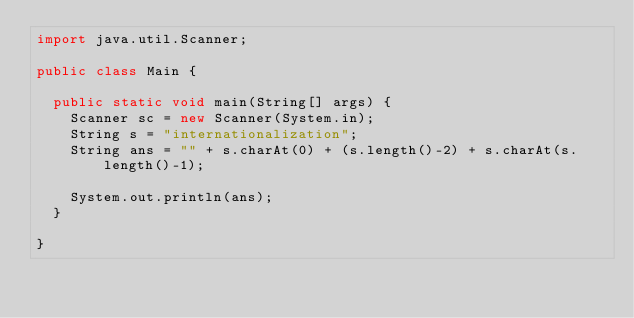Convert code to text. <code><loc_0><loc_0><loc_500><loc_500><_Java_>import java.util.Scanner;

public class Main {

	public static void main(String[] args) {
		Scanner sc = new Scanner(System.in);
		String s = "internationalization";
		String ans = "" + s.charAt(0) + (s.length()-2) + s.charAt(s.length()-1);

		System.out.println(ans);
	}

}</code> 